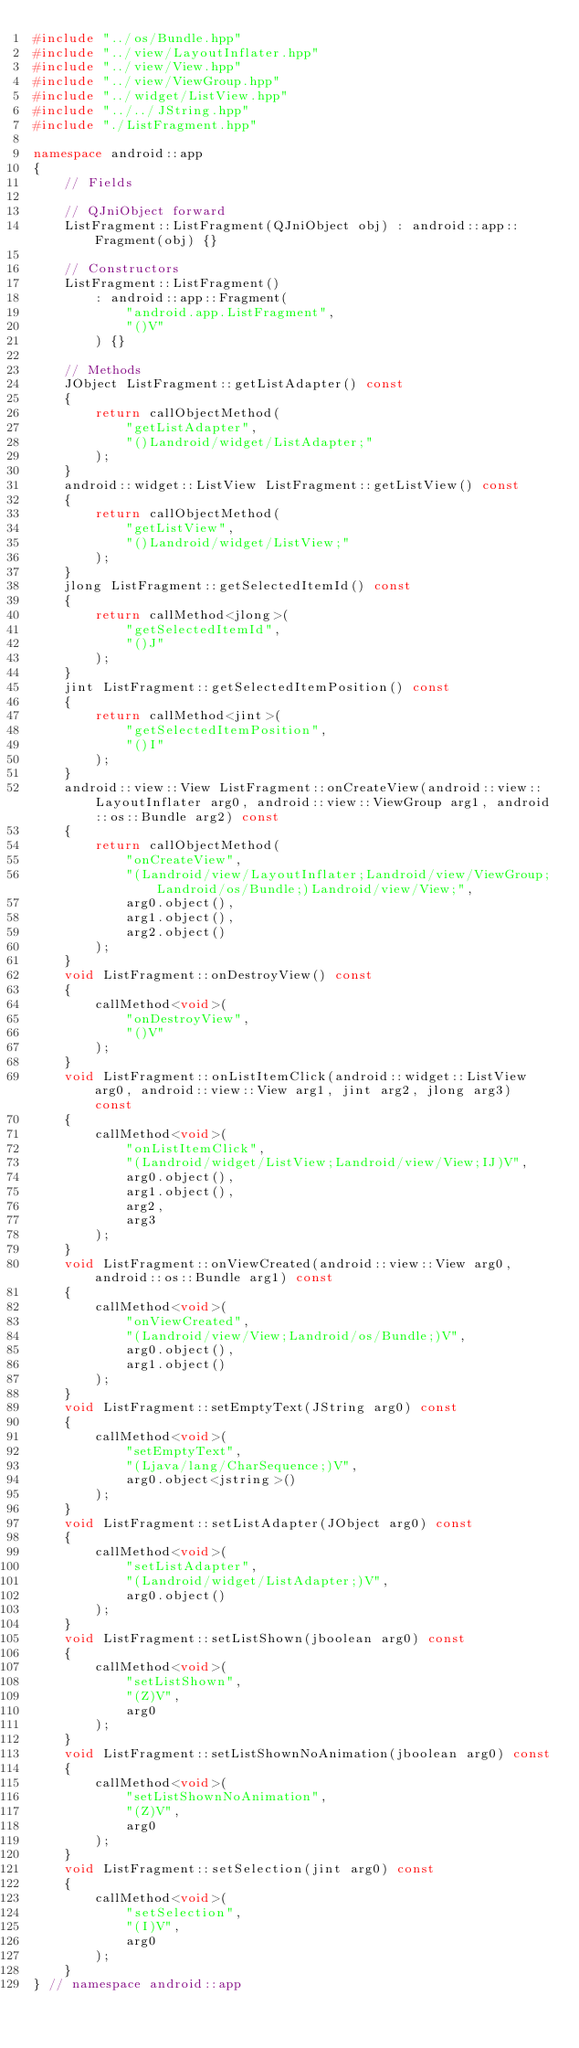Convert code to text. <code><loc_0><loc_0><loc_500><loc_500><_C++_>#include "../os/Bundle.hpp"
#include "../view/LayoutInflater.hpp"
#include "../view/View.hpp"
#include "../view/ViewGroup.hpp"
#include "../widget/ListView.hpp"
#include "../../JString.hpp"
#include "./ListFragment.hpp"

namespace android::app
{
	// Fields
	
	// QJniObject forward
	ListFragment::ListFragment(QJniObject obj) : android::app::Fragment(obj) {}
	
	// Constructors
	ListFragment::ListFragment()
		: android::app::Fragment(
			"android.app.ListFragment",
			"()V"
		) {}
	
	// Methods
	JObject ListFragment::getListAdapter() const
	{
		return callObjectMethod(
			"getListAdapter",
			"()Landroid/widget/ListAdapter;"
		);
	}
	android::widget::ListView ListFragment::getListView() const
	{
		return callObjectMethod(
			"getListView",
			"()Landroid/widget/ListView;"
		);
	}
	jlong ListFragment::getSelectedItemId() const
	{
		return callMethod<jlong>(
			"getSelectedItemId",
			"()J"
		);
	}
	jint ListFragment::getSelectedItemPosition() const
	{
		return callMethod<jint>(
			"getSelectedItemPosition",
			"()I"
		);
	}
	android::view::View ListFragment::onCreateView(android::view::LayoutInflater arg0, android::view::ViewGroup arg1, android::os::Bundle arg2) const
	{
		return callObjectMethod(
			"onCreateView",
			"(Landroid/view/LayoutInflater;Landroid/view/ViewGroup;Landroid/os/Bundle;)Landroid/view/View;",
			arg0.object(),
			arg1.object(),
			arg2.object()
		);
	}
	void ListFragment::onDestroyView() const
	{
		callMethod<void>(
			"onDestroyView",
			"()V"
		);
	}
	void ListFragment::onListItemClick(android::widget::ListView arg0, android::view::View arg1, jint arg2, jlong arg3) const
	{
		callMethod<void>(
			"onListItemClick",
			"(Landroid/widget/ListView;Landroid/view/View;IJ)V",
			arg0.object(),
			arg1.object(),
			arg2,
			arg3
		);
	}
	void ListFragment::onViewCreated(android::view::View arg0, android::os::Bundle arg1) const
	{
		callMethod<void>(
			"onViewCreated",
			"(Landroid/view/View;Landroid/os/Bundle;)V",
			arg0.object(),
			arg1.object()
		);
	}
	void ListFragment::setEmptyText(JString arg0) const
	{
		callMethod<void>(
			"setEmptyText",
			"(Ljava/lang/CharSequence;)V",
			arg0.object<jstring>()
		);
	}
	void ListFragment::setListAdapter(JObject arg0) const
	{
		callMethod<void>(
			"setListAdapter",
			"(Landroid/widget/ListAdapter;)V",
			arg0.object()
		);
	}
	void ListFragment::setListShown(jboolean arg0) const
	{
		callMethod<void>(
			"setListShown",
			"(Z)V",
			arg0
		);
	}
	void ListFragment::setListShownNoAnimation(jboolean arg0) const
	{
		callMethod<void>(
			"setListShownNoAnimation",
			"(Z)V",
			arg0
		);
	}
	void ListFragment::setSelection(jint arg0) const
	{
		callMethod<void>(
			"setSelection",
			"(I)V",
			arg0
		);
	}
} // namespace android::app

</code> 